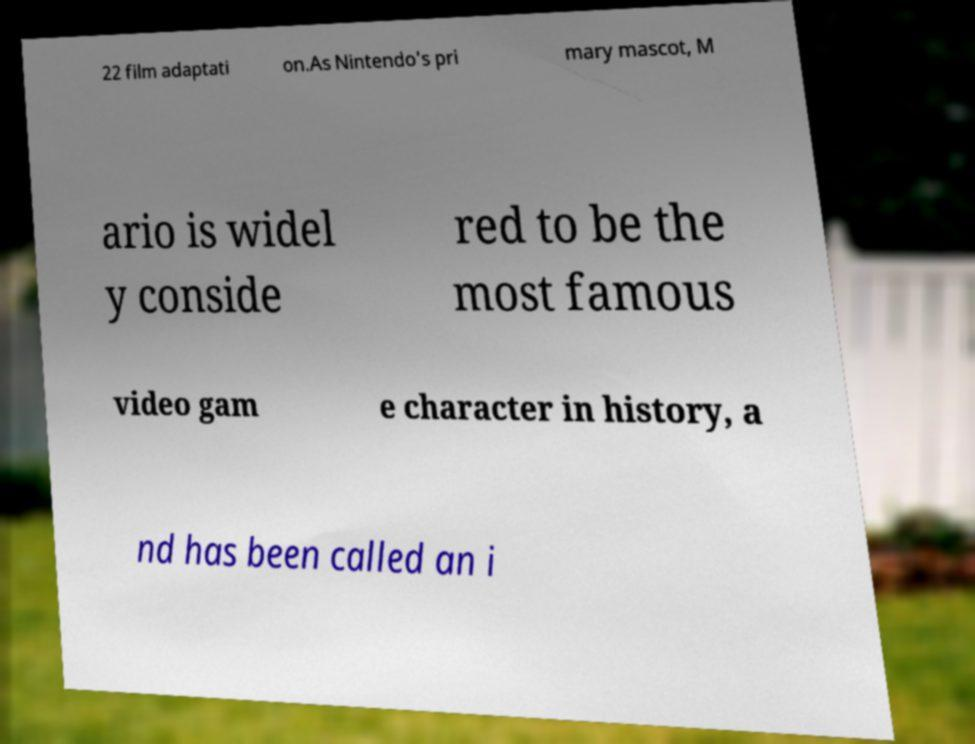I need the written content from this picture converted into text. Can you do that? 22 film adaptati on.As Nintendo's pri mary mascot, M ario is widel y conside red to be the most famous video gam e character in history, a nd has been called an i 